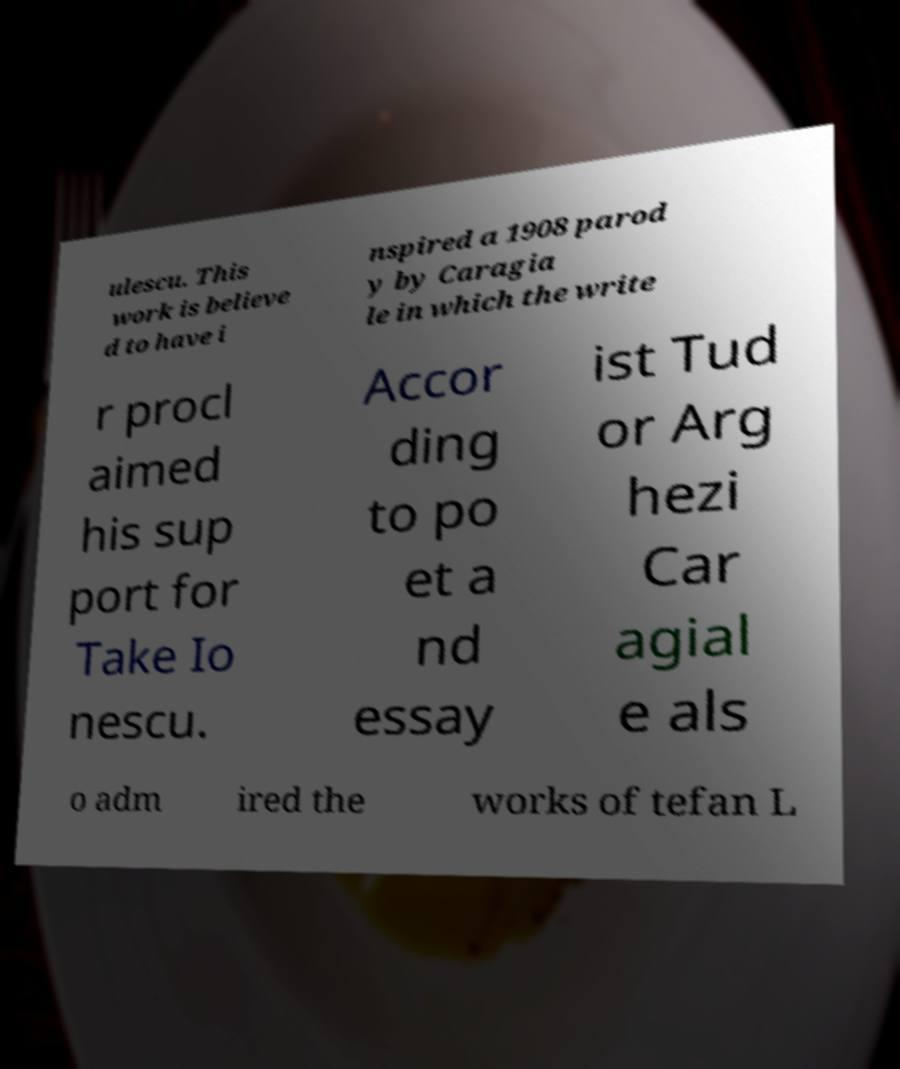Could you extract and type out the text from this image? ulescu. This work is believe d to have i nspired a 1908 parod y by Caragia le in which the write r procl aimed his sup port for Take Io nescu. Accor ding to po et a nd essay ist Tud or Arg hezi Car agial e als o adm ired the works of tefan L 